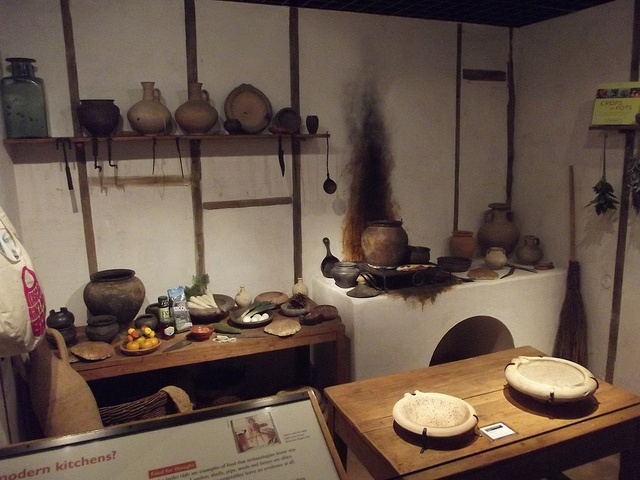Describe the objects in this image and their specific colors. I can see dining table in black, gray, and tan tones, vase in black, gray, brown, and maroon tones, handbag in black, tan, and maroon tones, bowl in black, tan, and lightyellow tones, and bowl in black, tan, and lightyellow tones in this image. 